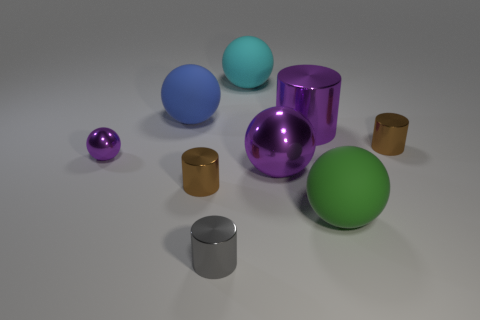Are the purple sphere to the left of the large cyan rubber sphere and the large cyan sphere made of the same material?
Offer a terse response. No. Are there any other things that have the same size as the gray cylinder?
Keep it short and to the point. Yes. There is a gray thing; are there any gray objects behind it?
Keep it short and to the point. No. There is a tiny cylinder that is right of the small metal cylinder in front of the large matte thing on the right side of the large purple cylinder; what color is it?
Your response must be concise. Brown. There is a blue rubber object that is the same size as the green thing; what shape is it?
Make the answer very short. Sphere. Is the number of brown matte cylinders greater than the number of big matte spheres?
Provide a succinct answer. No. Are there any brown things behind the purple shiny thing in front of the small purple object?
Your answer should be very brief. Yes. There is a tiny thing that is the same shape as the big green object; what color is it?
Ensure brevity in your answer.  Purple. Is there anything else that is the same shape as the tiny purple shiny thing?
Make the answer very short. Yes. The other ball that is the same material as the small purple ball is what color?
Your response must be concise. Purple. 